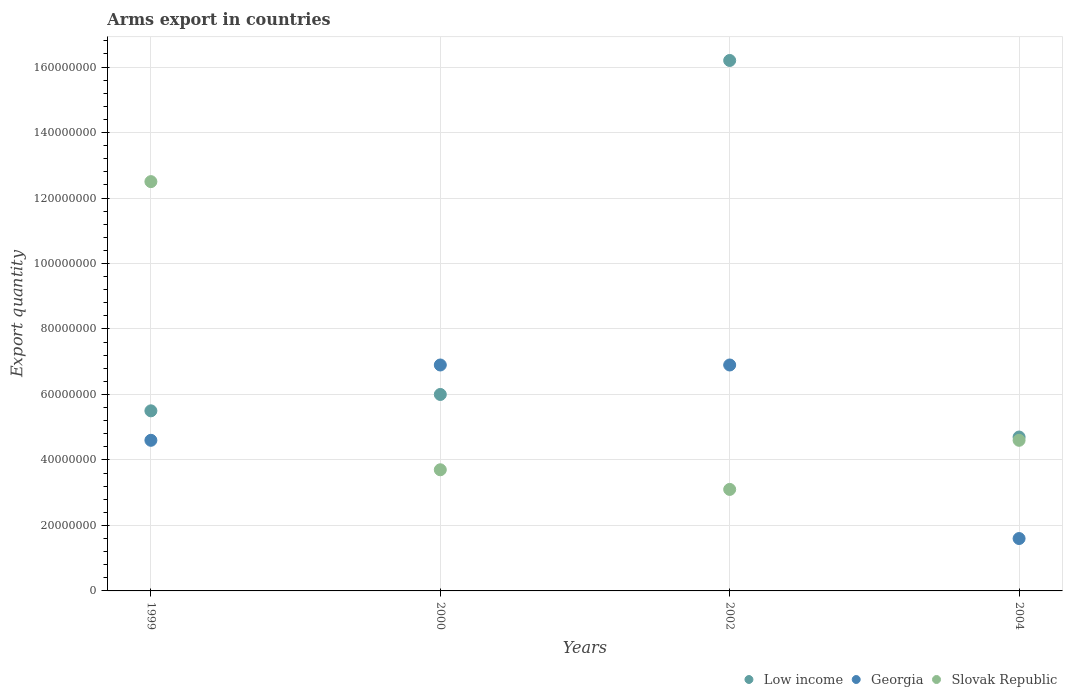How many different coloured dotlines are there?
Provide a succinct answer. 3. What is the total arms export in Slovak Republic in 2002?
Keep it short and to the point. 3.10e+07. Across all years, what is the maximum total arms export in Slovak Republic?
Your response must be concise. 1.25e+08. Across all years, what is the minimum total arms export in Slovak Republic?
Offer a very short reply. 3.10e+07. In which year was the total arms export in Georgia minimum?
Offer a very short reply. 2004. What is the difference between the total arms export in Slovak Republic in 1999 and that in 2004?
Provide a succinct answer. 7.90e+07. What is the difference between the total arms export in Georgia in 2004 and the total arms export in Low income in 1999?
Offer a terse response. -3.90e+07. What is the average total arms export in Low income per year?
Make the answer very short. 8.10e+07. In the year 2000, what is the difference between the total arms export in Low income and total arms export in Georgia?
Provide a short and direct response. -9.00e+06. In how many years, is the total arms export in Low income greater than 76000000?
Provide a succinct answer. 1. What is the ratio of the total arms export in Low income in 1999 to that in 2000?
Offer a terse response. 0.92. Is the total arms export in Low income in 1999 less than that in 2000?
Provide a succinct answer. Yes. Is the difference between the total arms export in Low income in 2002 and 2004 greater than the difference between the total arms export in Georgia in 2002 and 2004?
Provide a short and direct response. Yes. What is the difference between the highest and the second highest total arms export in Low income?
Give a very brief answer. 1.02e+08. What is the difference between the highest and the lowest total arms export in Slovak Republic?
Ensure brevity in your answer.  9.40e+07. In how many years, is the total arms export in Low income greater than the average total arms export in Low income taken over all years?
Provide a short and direct response. 1. Is it the case that in every year, the sum of the total arms export in Low income and total arms export in Georgia  is greater than the total arms export in Slovak Republic?
Provide a short and direct response. No. Is the total arms export in Georgia strictly greater than the total arms export in Low income over the years?
Provide a succinct answer. No. Is the total arms export in Slovak Republic strictly less than the total arms export in Low income over the years?
Your answer should be very brief. No. What is the difference between two consecutive major ticks on the Y-axis?
Offer a terse response. 2.00e+07. Are the values on the major ticks of Y-axis written in scientific E-notation?
Ensure brevity in your answer.  No. Does the graph contain any zero values?
Provide a short and direct response. No. Where does the legend appear in the graph?
Offer a very short reply. Bottom right. How are the legend labels stacked?
Provide a succinct answer. Horizontal. What is the title of the graph?
Provide a succinct answer. Arms export in countries. Does "Greece" appear as one of the legend labels in the graph?
Ensure brevity in your answer.  No. What is the label or title of the X-axis?
Your answer should be compact. Years. What is the label or title of the Y-axis?
Your response must be concise. Export quantity. What is the Export quantity in Low income in 1999?
Offer a very short reply. 5.50e+07. What is the Export quantity in Georgia in 1999?
Keep it short and to the point. 4.60e+07. What is the Export quantity in Slovak Republic in 1999?
Offer a very short reply. 1.25e+08. What is the Export quantity in Low income in 2000?
Ensure brevity in your answer.  6.00e+07. What is the Export quantity of Georgia in 2000?
Your answer should be very brief. 6.90e+07. What is the Export quantity in Slovak Republic in 2000?
Offer a terse response. 3.70e+07. What is the Export quantity in Low income in 2002?
Your answer should be very brief. 1.62e+08. What is the Export quantity in Georgia in 2002?
Provide a succinct answer. 6.90e+07. What is the Export quantity of Slovak Republic in 2002?
Make the answer very short. 3.10e+07. What is the Export quantity of Low income in 2004?
Keep it short and to the point. 4.70e+07. What is the Export quantity of Georgia in 2004?
Offer a terse response. 1.60e+07. What is the Export quantity in Slovak Republic in 2004?
Provide a succinct answer. 4.60e+07. Across all years, what is the maximum Export quantity of Low income?
Make the answer very short. 1.62e+08. Across all years, what is the maximum Export quantity in Georgia?
Your answer should be compact. 6.90e+07. Across all years, what is the maximum Export quantity of Slovak Republic?
Your answer should be very brief. 1.25e+08. Across all years, what is the minimum Export quantity in Low income?
Your response must be concise. 4.70e+07. Across all years, what is the minimum Export quantity of Georgia?
Provide a short and direct response. 1.60e+07. Across all years, what is the minimum Export quantity of Slovak Republic?
Make the answer very short. 3.10e+07. What is the total Export quantity of Low income in the graph?
Provide a succinct answer. 3.24e+08. What is the total Export quantity in Slovak Republic in the graph?
Offer a terse response. 2.39e+08. What is the difference between the Export quantity in Low income in 1999 and that in 2000?
Make the answer very short. -5.00e+06. What is the difference between the Export quantity of Georgia in 1999 and that in 2000?
Offer a very short reply. -2.30e+07. What is the difference between the Export quantity in Slovak Republic in 1999 and that in 2000?
Your answer should be very brief. 8.80e+07. What is the difference between the Export quantity in Low income in 1999 and that in 2002?
Your answer should be compact. -1.07e+08. What is the difference between the Export quantity in Georgia in 1999 and that in 2002?
Your answer should be very brief. -2.30e+07. What is the difference between the Export quantity in Slovak Republic in 1999 and that in 2002?
Your response must be concise. 9.40e+07. What is the difference between the Export quantity of Low income in 1999 and that in 2004?
Provide a succinct answer. 8.00e+06. What is the difference between the Export quantity of Georgia in 1999 and that in 2004?
Keep it short and to the point. 3.00e+07. What is the difference between the Export quantity in Slovak Republic in 1999 and that in 2004?
Your answer should be compact. 7.90e+07. What is the difference between the Export quantity in Low income in 2000 and that in 2002?
Your answer should be very brief. -1.02e+08. What is the difference between the Export quantity of Georgia in 2000 and that in 2002?
Make the answer very short. 0. What is the difference between the Export quantity in Low income in 2000 and that in 2004?
Offer a very short reply. 1.30e+07. What is the difference between the Export quantity of Georgia in 2000 and that in 2004?
Your response must be concise. 5.30e+07. What is the difference between the Export quantity of Slovak Republic in 2000 and that in 2004?
Your response must be concise. -9.00e+06. What is the difference between the Export quantity in Low income in 2002 and that in 2004?
Ensure brevity in your answer.  1.15e+08. What is the difference between the Export quantity of Georgia in 2002 and that in 2004?
Your answer should be very brief. 5.30e+07. What is the difference between the Export quantity in Slovak Republic in 2002 and that in 2004?
Keep it short and to the point. -1.50e+07. What is the difference between the Export quantity of Low income in 1999 and the Export quantity of Georgia in 2000?
Your answer should be very brief. -1.40e+07. What is the difference between the Export quantity in Low income in 1999 and the Export quantity in Slovak Republic in 2000?
Keep it short and to the point. 1.80e+07. What is the difference between the Export quantity of Georgia in 1999 and the Export quantity of Slovak Republic in 2000?
Make the answer very short. 9.00e+06. What is the difference between the Export quantity in Low income in 1999 and the Export quantity in Georgia in 2002?
Your answer should be very brief. -1.40e+07. What is the difference between the Export quantity in Low income in 1999 and the Export quantity in Slovak Republic in 2002?
Offer a very short reply. 2.40e+07. What is the difference between the Export quantity in Georgia in 1999 and the Export quantity in Slovak Republic in 2002?
Provide a short and direct response. 1.50e+07. What is the difference between the Export quantity in Low income in 1999 and the Export quantity in Georgia in 2004?
Ensure brevity in your answer.  3.90e+07. What is the difference between the Export quantity of Low income in 1999 and the Export quantity of Slovak Republic in 2004?
Offer a terse response. 9.00e+06. What is the difference between the Export quantity in Low income in 2000 and the Export quantity in Georgia in 2002?
Keep it short and to the point. -9.00e+06. What is the difference between the Export quantity of Low income in 2000 and the Export quantity of Slovak Republic in 2002?
Your answer should be compact. 2.90e+07. What is the difference between the Export quantity in Georgia in 2000 and the Export quantity in Slovak Republic in 2002?
Your response must be concise. 3.80e+07. What is the difference between the Export quantity in Low income in 2000 and the Export quantity in Georgia in 2004?
Ensure brevity in your answer.  4.40e+07. What is the difference between the Export quantity in Low income in 2000 and the Export quantity in Slovak Republic in 2004?
Ensure brevity in your answer.  1.40e+07. What is the difference between the Export quantity of Georgia in 2000 and the Export quantity of Slovak Republic in 2004?
Your answer should be compact. 2.30e+07. What is the difference between the Export quantity of Low income in 2002 and the Export quantity of Georgia in 2004?
Ensure brevity in your answer.  1.46e+08. What is the difference between the Export quantity in Low income in 2002 and the Export quantity in Slovak Republic in 2004?
Make the answer very short. 1.16e+08. What is the difference between the Export quantity of Georgia in 2002 and the Export quantity of Slovak Republic in 2004?
Make the answer very short. 2.30e+07. What is the average Export quantity in Low income per year?
Offer a terse response. 8.10e+07. What is the average Export quantity of Georgia per year?
Offer a terse response. 5.00e+07. What is the average Export quantity of Slovak Republic per year?
Make the answer very short. 5.98e+07. In the year 1999, what is the difference between the Export quantity of Low income and Export quantity of Georgia?
Your answer should be very brief. 9.00e+06. In the year 1999, what is the difference between the Export quantity in Low income and Export quantity in Slovak Republic?
Keep it short and to the point. -7.00e+07. In the year 1999, what is the difference between the Export quantity of Georgia and Export quantity of Slovak Republic?
Offer a very short reply. -7.90e+07. In the year 2000, what is the difference between the Export quantity in Low income and Export quantity in Georgia?
Offer a terse response. -9.00e+06. In the year 2000, what is the difference between the Export quantity in Low income and Export quantity in Slovak Republic?
Your answer should be very brief. 2.30e+07. In the year 2000, what is the difference between the Export quantity in Georgia and Export quantity in Slovak Republic?
Provide a succinct answer. 3.20e+07. In the year 2002, what is the difference between the Export quantity of Low income and Export quantity of Georgia?
Provide a succinct answer. 9.30e+07. In the year 2002, what is the difference between the Export quantity of Low income and Export quantity of Slovak Republic?
Offer a terse response. 1.31e+08. In the year 2002, what is the difference between the Export quantity of Georgia and Export quantity of Slovak Republic?
Your answer should be very brief. 3.80e+07. In the year 2004, what is the difference between the Export quantity of Low income and Export quantity of Georgia?
Give a very brief answer. 3.10e+07. In the year 2004, what is the difference between the Export quantity of Georgia and Export quantity of Slovak Republic?
Provide a succinct answer. -3.00e+07. What is the ratio of the Export quantity in Low income in 1999 to that in 2000?
Your answer should be compact. 0.92. What is the ratio of the Export quantity of Slovak Republic in 1999 to that in 2000?
Provide a short and direct response. 3.38. What is the ratio of the Export quantity in Low income in 1999 to that in 2002?
Keep it short and to the point. 0.34. What is the ratio of the Export quantity in Slovak Republic in 1999 to that in 2002?
Your answer should be compact. 4.03. What is the ratio of the Export quantity in Low income in 1999 to that in 2004?
Provide a short and direct response. 1.17. What is the ratio of the Export quantity of Georgia in 1999 to that in 2004?
Offer a very short reply. 2.88. What is the ratio of the Export quantity of Slovak Republic in 1999 to that in 2004?
Offer a terse response. 2.72. What is the ratio of the Export quantity of Low income in 2000 to that in 2002?
Your answer should be compact. 0.37. What is the ratio of the Export quantity in Slovak Republic in 2000 to that in 2002?
Your answer should be very brief. 1.19. What is the ratio of the Export quantity in Low income in 2000 to that in 2004?
Make the answer very short. 1.28. What is the ratio of the Export quantity of Georgia in 2000 to that in 2004?
Keep it short and to the point. 4.31. What is the ratio of the Export quantity of Slovak Republic in 2000 to that in 2004?
Offer a terse response. 0.8. What is the ratio of the Export quantity of Low income in 2002 to that in 2004?
Provide a succinct answer. 3.45. What is the ratio of the Export quantity in Georgia in 2002 to that in 2004?
Offer a very short reply. 4.31. What is the ratio of the Export quantity of Slovak Republic in 2002 to that in 2004?
Give a very brief answer. 0.67. What is the difference between the highest and the second highest Export quantity in Low income?
Your answer should be very brief. 1.02e+08. What is the difference between the highest and the second highest Export quantity of Georgia?
Ensure brevity in your answer.  0. What is the difference between the highest and the second highest Export quantity of Slovak Republic?
Your response must be concise. 7.90e+07. What is the difference between the highest and the lowest Export quantity in Low income?
Your answer should be compact. 1.15e+08. What is the difference between the highest and the lowest Export quantity of Georgia?
Keep it short and to the point. 5.30e+07. What is the difference between the highest and the lowest Export quantity in Slovak Republic?
Keep it short and to the point. 9.40e+07. 